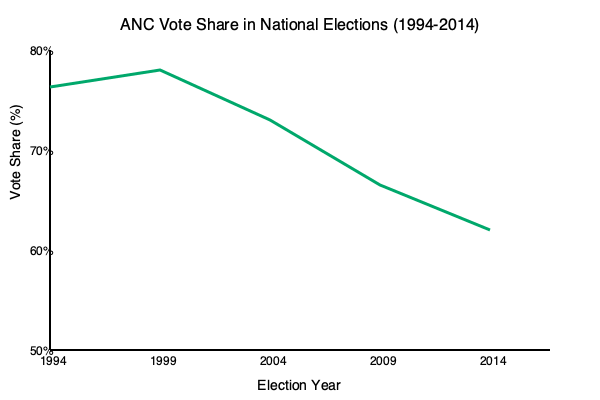Analyze the trend of the ANC's vote share in national elections from 1994 to 2014 as shown in the line graph. What does this trend suggest about the party's electoral performance over time, and what implications might this have for future elections? To analyze the trend of the ANC's vote share, let's examine the graph step-by-step:

1. 1994 Election: The ANC starts with a high vote share of approximately 77%.

2. 1999 Election: There's a slight increase to about 79%, showing a peak in popular support.

3. 2004 Election: The vote share decreases to around 70%, indicating a significant drop in support.

4. 2009 Election: Another decrease is observed, with the vote share falling to about 65%.

5. 2014 Election: The downward trend continues, with the vote share dropping to approximately 62%.

The overall trend shows a clear decline in the ANC's vote share from 1999 to 2014, despite the initial increase between 1994 and 1999.

This trend suggests:

1. Initial consolidation of power: The increase from 1994 to 1999 might reflect the ANC's ability to consolidate its support base after the end of apartheid.

2. Gradual erosion of support: The consistent decrease from 1999 to 2014 indicates a gradual loss of voter confidence or the rise of competitive political alternatives.

3. Challenges to dominance: While the ANC maintains a majority, the declining trend suggests increasing challenges to its political dominance.

Implications for future elections:

1. If this trend continues, the ANC might face the risk of losing its majority in future elections.
2. The party may need to address internal issues or policy concerns to reverse this trend.
3. There might be a shift towards a more competitive multi-party democracy in South Africa.

However, it's important to note that the ANC still maintains a significant majority despite the decline, indicating its continued importance in South African politics.
Answer: Declining vote share since 1999, indicating eroding support but maintained majority; suggests potential future challenges to ANC dominance. 